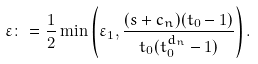<formula> <loc_0><loc_0><loc_500><loc_500>\varepsilon \colon = \frac { 1 } { 2 } \min \left ( \varepsilon _ { 1 } , \frac { ( s + c _ { n } ) ( t _ { 0 } - 1 ) } { t _ { 0 } ( t _ { 0 } ^ { d _ { n } } - 1 ) } \right ) .</formula> 